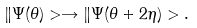Convert formula to latex. <formula><loc_0><loc_0><loc_500><loc_500>\| \Psi ( \theta ) > \rightarrow \| \Psi ( \theta + 2 \eta ) > .</formula> 